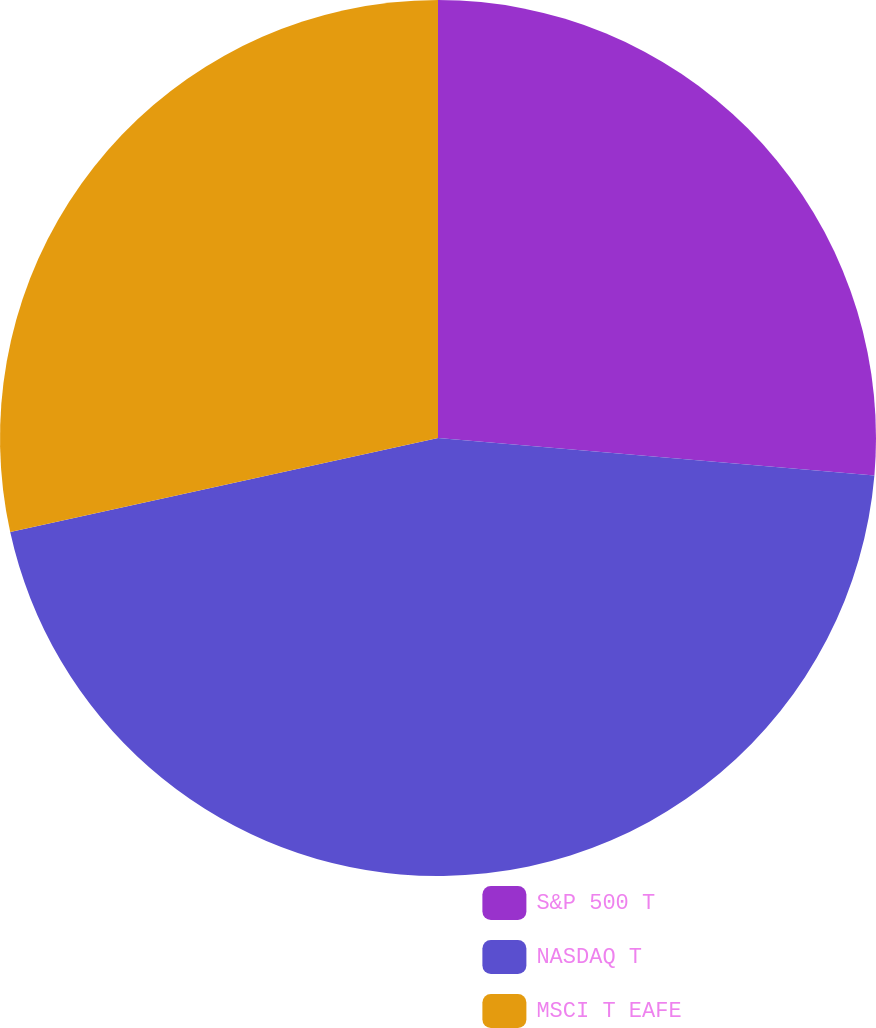Convert chart. <chart><loc_0><loc_0><loc_500><loc_500><pie_chart><fcel>S&P 500 T<fcel>NASDAQ T<fcel>MSCI T EAFE<nl><fcel>26.36%<fcel>45.19%<fcel>28.44%<nl></chart> 